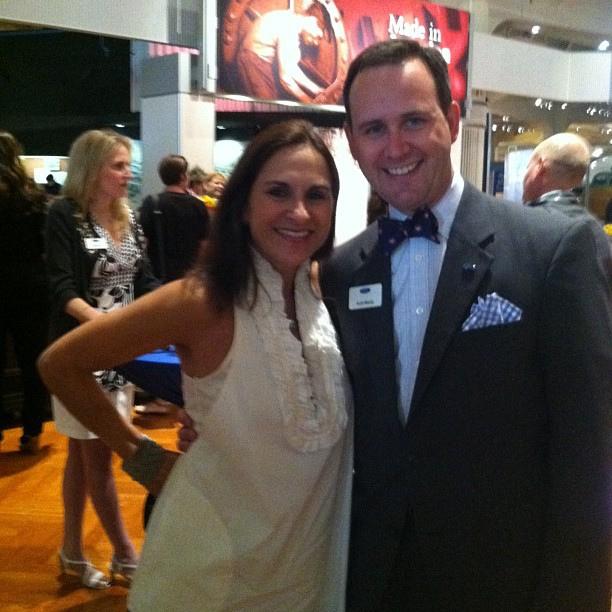Is the man wearing a name tag?
Concise answer only. Yes. What type of tie does the man have on?
Concise answer only. Bow tie. What color is the woman's dress?
Concise answer only. White. Are the people in the picture the same race?
Answer briefly. Yes. 